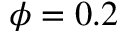<formula> <loc_0><loc_0><loc_500><loc_500>\phi = 0 . 2</formula> 